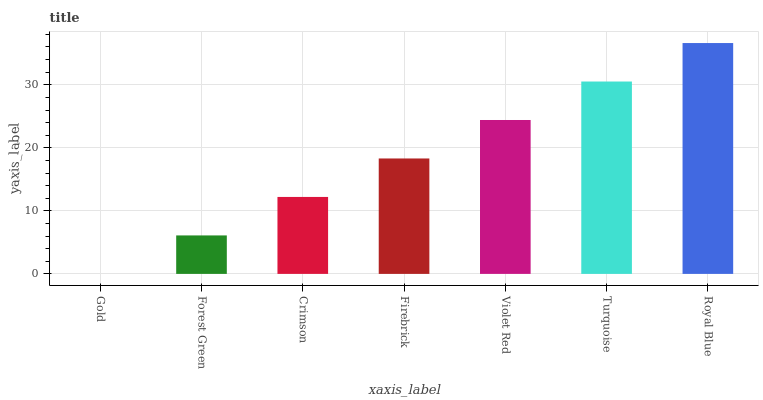Is Gold the minimum?
Answer yes or no. Yes. Is Royal Blue the maximum?
Answer yes or no. Yes. Is Forest Green the minimum?
Answer yes or no. No. Is Forest Green the maximum?
Answer yes or no. No. Is Forest Green greater than Gold?
Answer yes or no. Yes. Is Gold less than Forest Green?
Answer yes or no. Yes. Is Gold greater than Forest Green?
Answer yes or no. No. Is Forest Green less than Gold?
Answer yes or no. No. Is Firebrick the high median?
Answer yes or no. Yes. Is Firebrick the low median?
Answer yes or no. Yes. Is Crimson the high median?
Answer yes or no. No. Is Gold the low median?
Answer yes or no. No. 